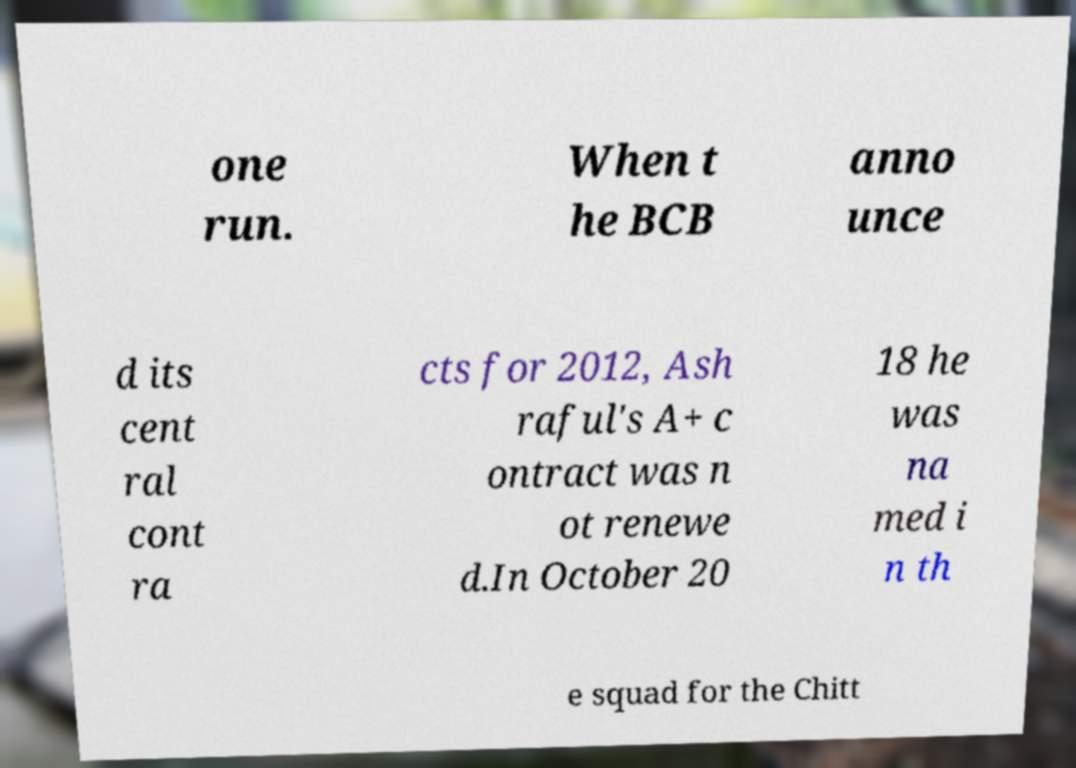What messages or text are displayed in this image? I need them in a readable, typed format. one run. When t he BCB anno unce d its cent ral cont ra cts for 2012, Ash raful's A+ c ontract was n ot renewe d.In October 20 18 he was na med i n th e squad for the Chitt 